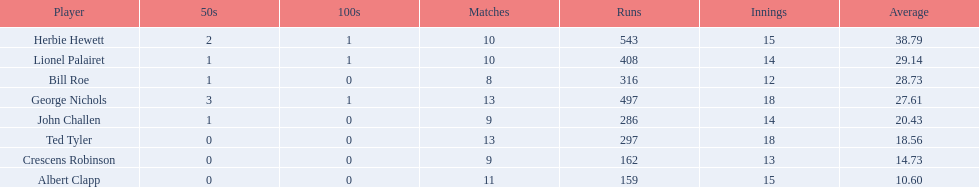Who are all of the players? Herbie Hewett, Lionel Palairet, Bill Roe, George Nichols, John Challen, Ted Tyler, Crescens Robinson, Albert Clapp. How many innings did they play in? 15, 14, 12, 18, 14, 18, 13, 15. Which player was in fewer than 13 innings? Bill Roe. 